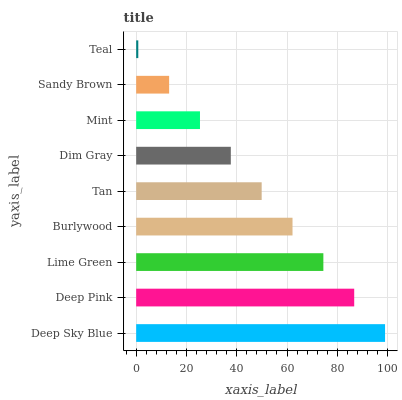Is Teal the minimum?
Answer yes or no. Yes. Is Deep Sky Blue the maximum?
Answer yes or no. Yes. Is Deep Pink the minimum?
Answer yes or no. No. Is Deep Pink the maximum?
Answer yes or no. No. Is Deep Sky Blue greater than Deep Pink?
Answer yes or no. Yes. Is Deep Pink less than Deep Sky Blue?
Answer yes or no. Yes. Is Deep Pink greater than Deep Sky Blue?
Answer yes or no. No. Is Deep Sky Blue less than Deep Pink?
Answer yes or no. No. Is Tan the high median?
Answer yes or no. Yes. Is Tan the low median?
Answer yes or no. Yes. Is Dim Gray the high median?
Answer yes or no. No. Is Teal the low median?
Answer yes or no. No. 